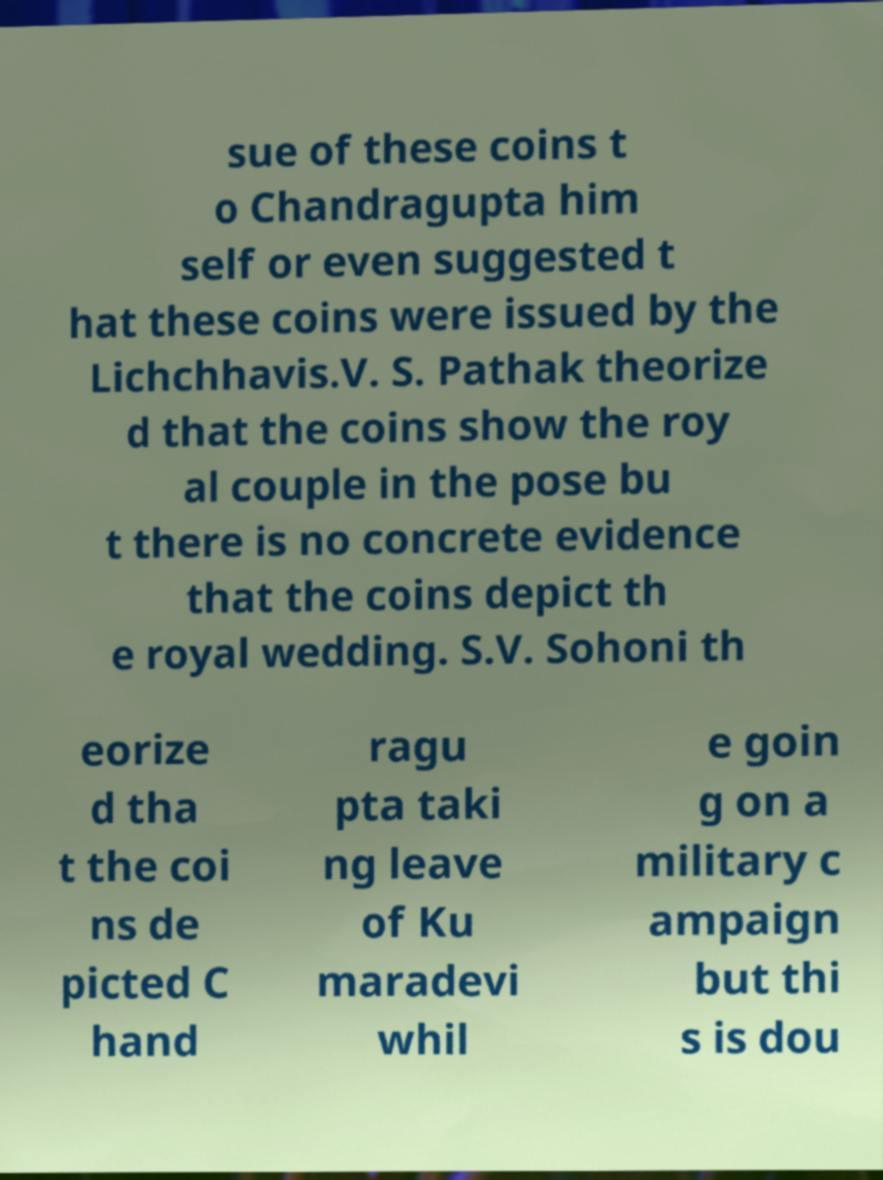Please identify and transcribe the text found in this image. sue of these coins t o Chandragupta him self or even suggested t hat these coins were issued by the Lichchhavis.V. S. Pathak theorize d that the coins show the roy al couple in the pose bu t there is no concrete evidence that the coins depict th e royal wedding. S.V. Sohoni th eorize d tha t the coi ns de picted C hand ragu pta taki ng leave of Ku maradevi whil e goin g on a military c ampaign but thi s is dou 